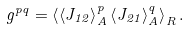<formula> <loc_0><loc_0><loc_500><loc_500>g ^ { p q } = \left \langle \left \langle J _ { 1 2 } \right \rangle _ { A } ^ { p } \left \langle J _ { 2 1 } \right \rangle _ { A } ^ { q } \right \rangle _ { R } .</formula> 